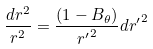Convert formula to latex. <formula><loc_0><loc_0><loc_500><loc_500>\frac { d r ^ { 2 } } { r ^ { 2 } } = \frac { ( 1 - B _ { \theta } ) } { { r ^ { \prime } } ^ { 2 } } d { r ^ { \prime } } ^ { 2 }</formula> 